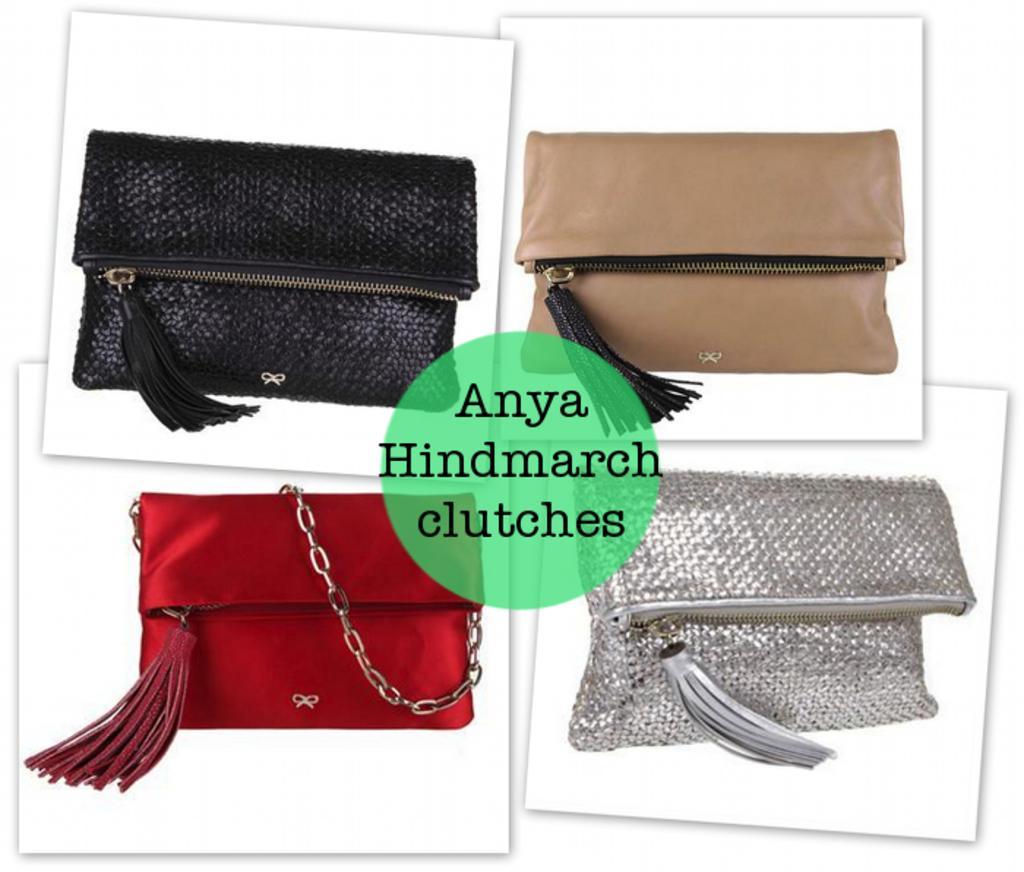How would you summarize this image in a sentence or two? The picture is a collage of four images. In the center of the picture there is some text. The picture has four handbags. The handbags are of different colors. At the top to the left there is a black bag. At the bottom there are red and silver color bags. At the top to the left it is blank, to the right it is brown. 